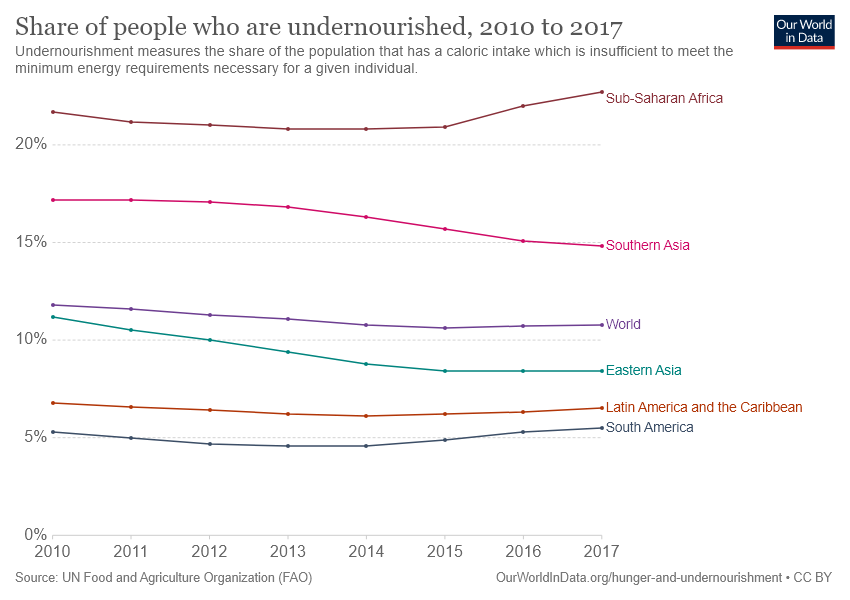Indicate a few pertinent items in this graphic. Six dotted lines are utilized to represent the graph. The share of people who are undernourished in Southern Asia is greater than that of Eastern Asia over the years. 